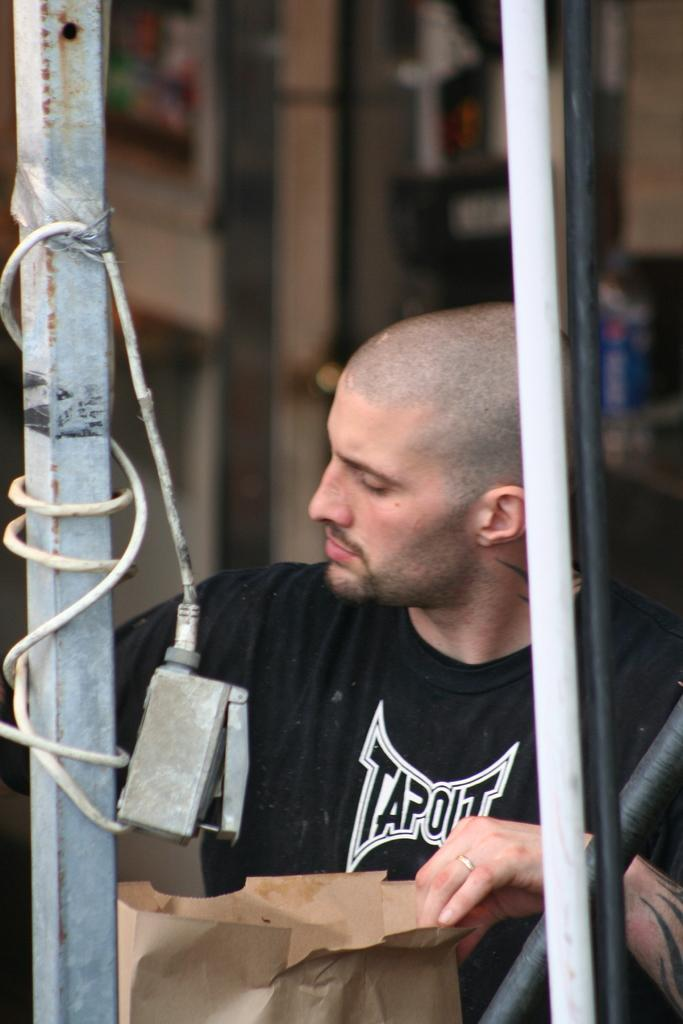What is the person holding in the image? The person is holding a paper bag. What can be seen in front of the person? There are poles in front of the person. What is attached to one of the poles? There is a device attached to one of the poles. How is the device connected to the pole? There is a cable connected to the device. Can you describe the background of the image? The background of the image is blurred. What type of pencil can be seen in the hand of the person holding the paper bag? There is no pencil visible in the image; the person is holding a paper bag. Are there any dinosaurs present in the image? No, there are no dinosaurs present in the image. 